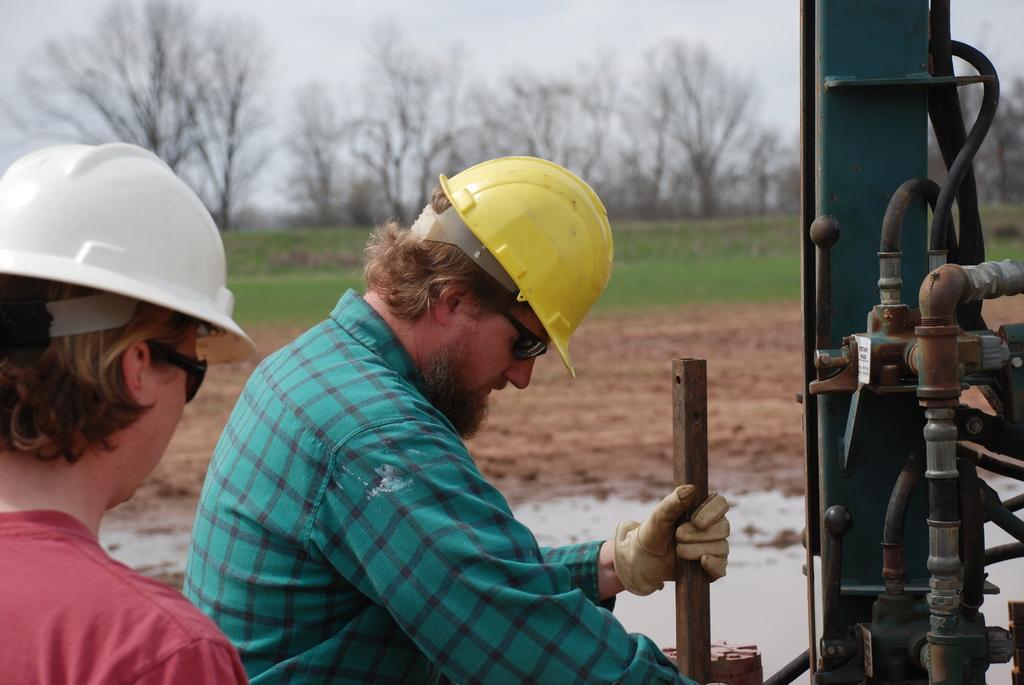Please provide a concise description of this image. In this image there are persons standing and wearing helmet and holding an object, At side there is a machine. At backside there are trees, Grass, Sand and sky. 